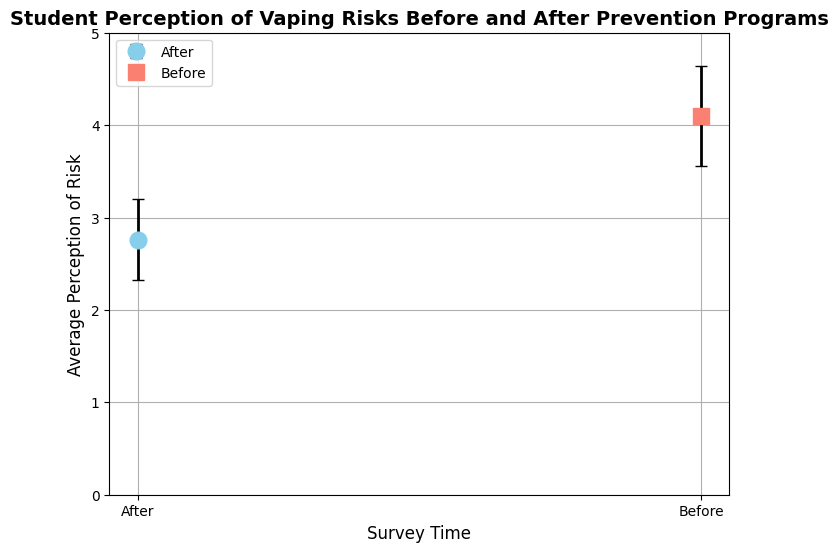What's the average perception of vaping risks before the prevention programs? To determine the average perception before the prevention programs, look at the "Before" survey data points. We see values of 4.2, 4.1, 3.9, 4.0, and 4.3. Sum these and divide by the number of data points (5): (4.2 + 4.1 + 3.9 + 4.0 + 4.3) / 5 = 20.5 / 5 = 4.1
Answer: 4.1 What's the difference in average perception of vaping risks before and after the prevention programs? First, calculate the average perception before, which is 4.1. Then calculate the average perception after, using 2.8, 2.7, 2.6, 2.9, and 2.8: (2.8 + 2.7 + 2.6 + 2.9 + 2.8) / 5 = 13.8 / 5 = 2.76. The difference is 4.1 - 2.76
Answer: 1.34 Which survey time has a higher perception of vaping risks, before or after the prevention programs? By comparing the average perceptions, the "Before" group has an average of 4.1, whereas the "After" group has an average of 2.76. Thus, the "Before" group has a higher perception of vaping risks
Answer: Before How do the error bars compare between the survey times before and after the prevention programs? Look at the error bars for both survey times. For the "Before" group, the average error bars are longer compared to the "After" group (0.54 vs. 0.44). This means the variability in survey responses is higher before the prevention programs
Answer: Higher before What is the relative reduction in average perception of vaping risks after the prevention programs compared to before? To find the relative reduction, use the formula: (Average Before - Average After) / Average Before. With averages of 4.1 (before) and 2.76 (after): (4.1 - 2.76) / 4.1 = 1.34 / 4.1 ≈ 0.327, or 32.7% reduction
Answer: 32.7% What are the colors used to represent the survey times, before and after? Observe the color-coded markers; the "Before" group uses a light blue color, and the "After" group uses a salmon color
Answer: Light blue for Before, Salmon for After What does the capsize in the error bars indicate? The capsize lines on the error bars show the variability in the survey responses. Longer capsize lines suggest higher variability or uncertainty in those responses
Answer: Variability in responses Which survey time shows less variability in perception of vaping risks? Compare the lengths of the error bars; shorter error bars reflect less variability. The "After" group's error bars are consistently shorter, indicating less variability in perceptions of vaping risks
Answer: After Considering the data, what might be a reason for the reduction in average perception of vaping risks after the prevention programs? One plausible explanation for the reduced perception of vaping risks after prevention programs is increased awareness and education, which may lead students to perceive vaping as less risky than initially believed
Answer: Increased awareness 